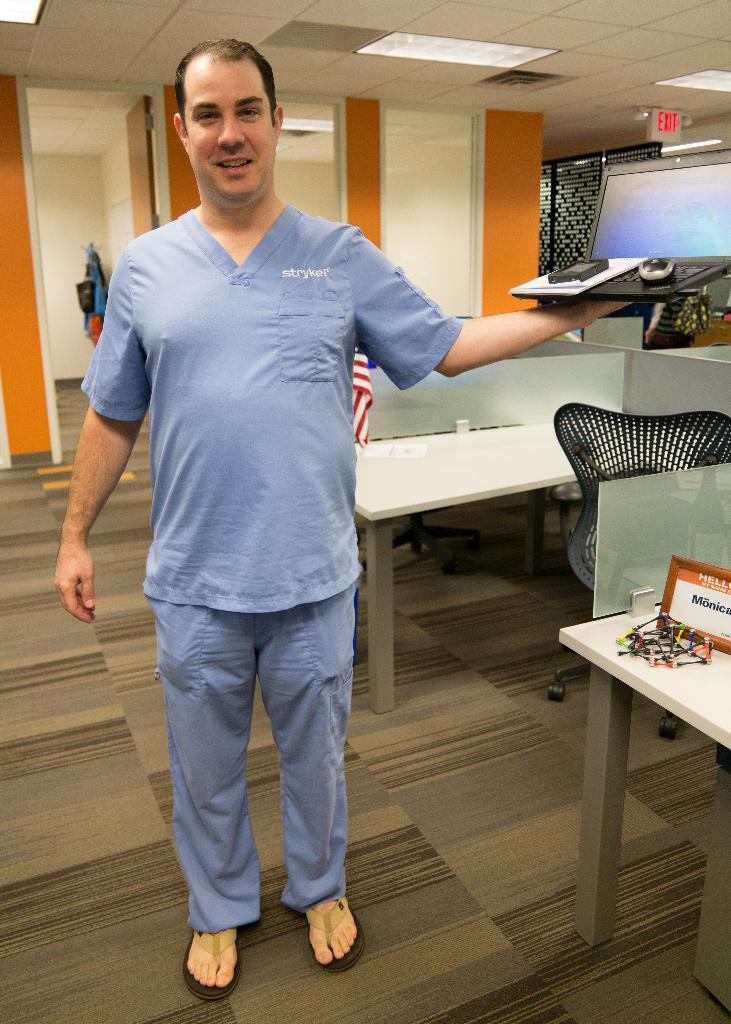What is the person in the image wearing? The person is wearing a blue dress. What object is the person holding in the image? The person is holding a laptop. Can you describe the background of the image? There is a chair and a table in the background of the image, and the wall has an orange and cream color. What type of receipt can be seen on the dock in the image? There is no dock or receipt present in the image. Can you describe the sponge used for cleaning the table in the image? There is no sponge visible in the image; it only shows a person holding a laptop and the background setting. 